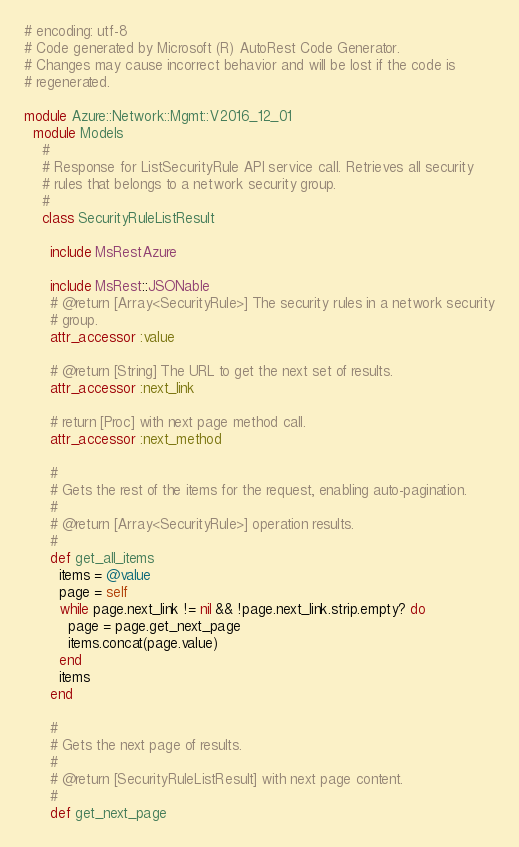<code> <loc_0><loc_0><loc_500><loc_500><_Ruby_># encoding: utf-8
# Code generated by Microsoft (R) AutoRest Code Generator.
# Changes may cause incorrect behavior and will be lost if the code is
# regenerated.

module Azure::Network::Mgmt::V2016_12_01
  module Models
    #
    # Response for ListSecurityRule API service call. Retrieves all security
    # rules that belongs to a network security group.
    #
    class SecurityRuleListResult

      include MsRestAzure

      include MsRest::JSONable
      # @return [Array<SecurityRule>] The security rules in a network security
      # group.
      attr_accessor :value

      # @return [String] The URL to get the next set of results.
      attr_accessor :next_link

      # return [Proc] with next page method call.
      attr_accessor :next_method

      #
      # Gets the rest of the items for the request, enabling auto-pagination.
      #
      # @return [Array<SecurityRule>] operation results.
      #
      def get_all_items
        items = @value
        page = self
        while page.next_link != nil && !page.next_link.strip.empty? do
          page = page.get_next_page
          items.concat(page.value)
        end
        items
      end

      #
      # Gets the next page of results.
      #
      # @return [SecurityRuleListResult] with next page content.
      #
      def get_next_page</code> 